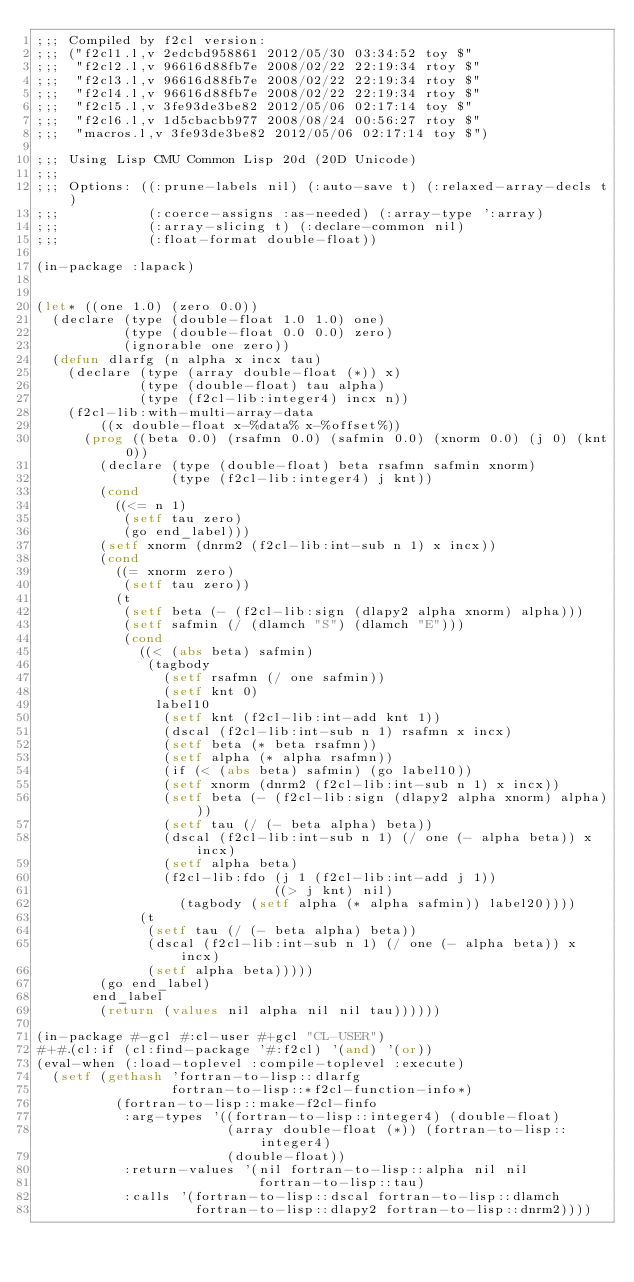<code> <loc_0><loc_0><loc_500><loc_500><_Lisp_>;;; Compiled by f2cl version:
;;; ("f2cl1.l,v 2edcbd958861 2012/05/30 03:34:52 toy $"
;;;  "f2cl2.l,v 96616d88fb7e 2008/02/22 22:19:34 rtoy $"
;;;  "f2cl3.l,v 96616d88fb7e 2008/02/22 22:19:34 rtoy $"
;;;  "f2cl4.l,v 96616d88fb7e 2008/02/22 22:19:34 rtoy $"
;;;  "f2cl5.l,v 3fe93de3be82 2012/05/06 02:17:14 toy $"
;;;  "f2cl6.l,v 1d5cbacbb977 2008/08/24 00:56:27 rtoy $"
;;;  "macros.l,v 3fe93de3be82 2012/05/06 02:17:14 toy $")

;;; Using Lisp CMU Common Lisp 20d (20D Unicode)
;;; 
;;; Options: ((:prune-labels nil) (:auto-save t) (:relaxed-array-decls t)
;;;           (:coerce-assigns :as-needed) (:array-type ':array)
;;;           (:array-slicing t) (:declare-common nil)
;;;           (:float-format double-float))

(in-package :lapack)


(let* ((one 1.0) (zero 0.0))
  (declare (type (double-float 1.0 1.0) one)
           (type (double-float 0.0 0.0) zero)
           (ignorable one zero))
  (defun dlarfg (n alpha x incx tau)
    (declare (type (array double-float (*)) x)
             (type (double-float) tau alpha)
             (type (f2cl-lib:integer4) incx n))
    (f2cl-lib:with-multi-array-data
        ((x double-float x-%data% x-%offset%))
      (prog ((beta 0.0) (rsafmn 0.0) (safmin 0.0) (xnorm 0.0) (j 0) (knt 0))
        (declare (type (double-float) beta rsafmn safmin xnorm)
                 (type (f2cl-lib:integer4) j knt))
        (cond
          ((<= n 1)
           (setf tau zero)
           (go end_label)))
        (setf xnorm (dnrm2 (f2cl-lib:int-sub n 1) x incx))
        (cond
          ((= xnorm zero)
           (setf tau zero))
          (t
           (setf beta (- (f2cl-lib:sign (dlapy2 alpha xnorm) alpha)))
           (setf safmin (/ (dlamch "S") (dlamch "E")))
           (cond
             ((< (abs beta) safmin)
              (tagbody
                (setf rsafmn (/ one safmin))
                (setf knt 0)
               label10
                (setf knt (f2cl-lib:int-add knt 1))
                (dscal (f2cl-lib:int-sub n 1) rsafmn x incx)
                (setf beta (* beta rsafmn))
                (setf alpha (* alpha rsafmn))
                (if (< (abs beta) safmin) (go label10))
                (setf xnorm (dnrm2 (f2cl-lib:int-sub n 1) x incx))
                (setf beta (- (f2cl-lib:sign (dlapy2 alpha xnorm) alpha)))
                (setf tau (/ (- beta alpha) beta))
                (dscal (f2cl-lib:int-sub n 1) (/ one (- alpha beta)) x incx)
                (setf alpha beta)
                (f2cl-lib:fdo (j 1 (f2cl-lib:int-add j 1))
                              ((> j knt) nil)
                  (tagbody (setf alpha (* alpha safmin)) label20))))
             (t
              (setf tau (/ (- beta alpha) beta))
              (dscal (f2cl-lib:int-sub n 1) (/ one (- alpha beta)) x incx)
              (setf alpha beta)))))
        (go end_label)
       end_label
        (return (values nil alpha nil nil tau))))))

(in-package #-gcl #:cl-user #+gcl "CL-USER")
#+#.(cl:if (cl:find-package '#:f2cl) '(and) '(or))
(eval-when (:load-toplevel :compile-toplevel :execute)
  (setf (gethash 'fortran-to-lisp::dlarfg
                 fortran-to-lisp::*f2cl-function-info*)
          (fortran-to-lisp::make-f2cl-finfo
           :arg-types '((fortran-to-lisp::integer4) (double-float)
                        (array double-float (*)) (fortran-to-lisp::integer4)
                        (double-float))
           :return-values '(nil fortran-to-lisp::alpha nil nil
                            fortran-to-lisp::tau)
           :calls '(fortran-to-lisp::dscal fortran-to-lisp::dlamch
                    fortran-to-lisp::dlapy2 fortran-to-lisp::dnrm2))))

</code> 